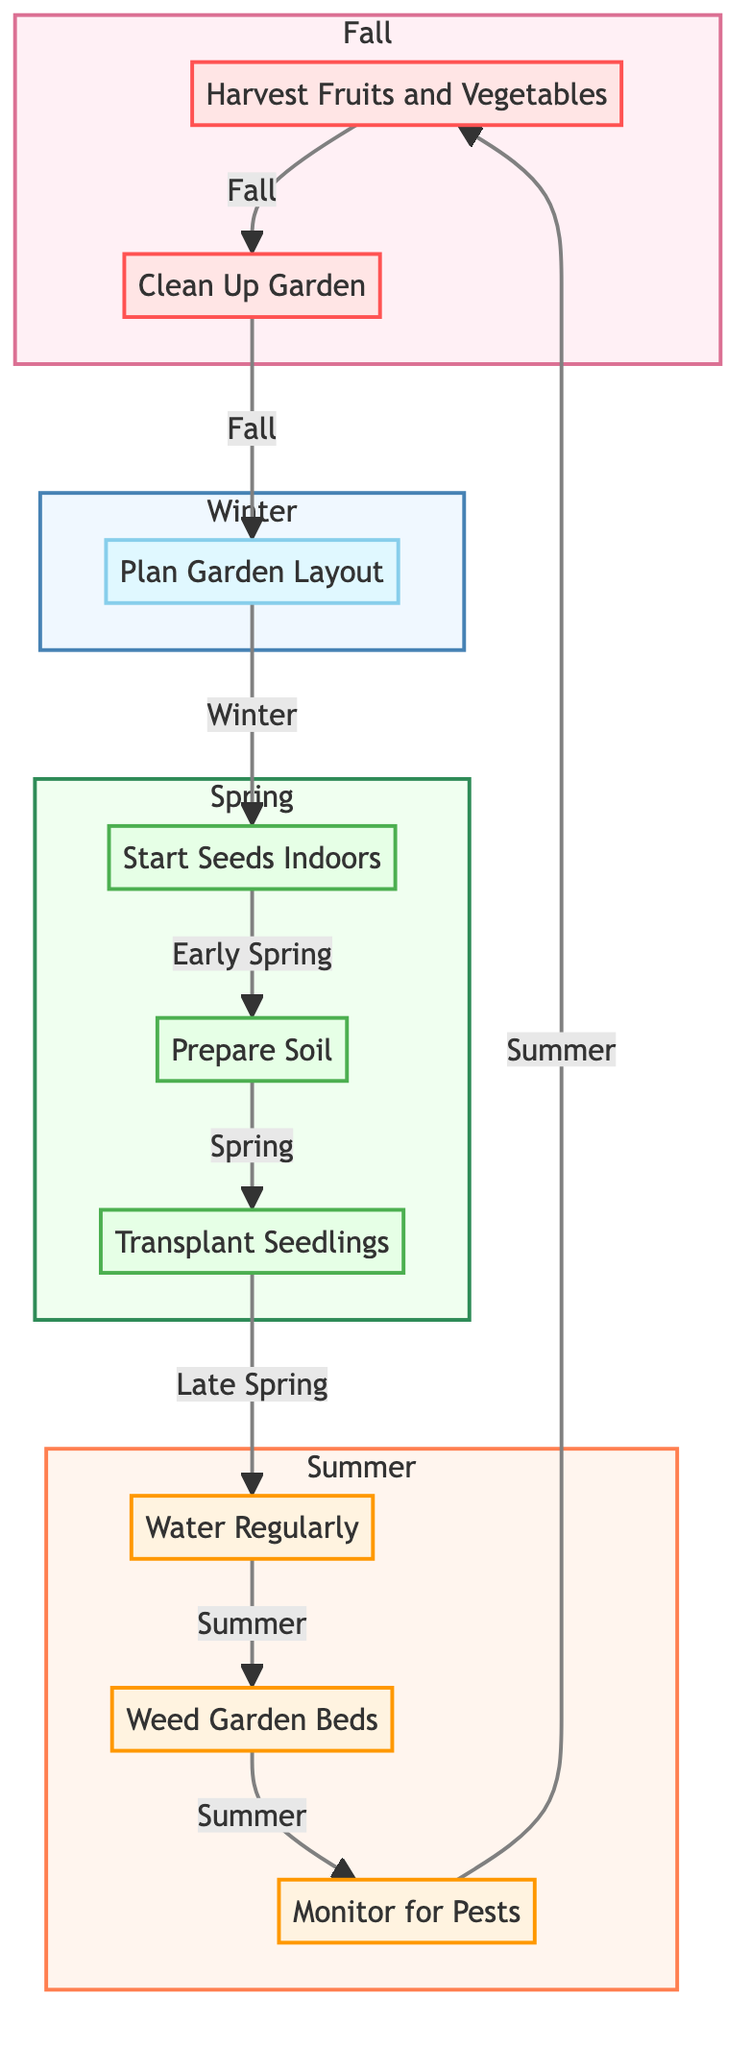What is the first task in the gardening flowchart? The flowchart starts with the node labeled "Plan Garden Layout" which represents the first task categorized under Winter.
Answer: Plan Garden Layout How many tasks are associated with the Spring season? There are three tasks labeled under the Spring season: "Start Seeds Indoors", "Prepare Soil", and "Transplant Seedlings", making a total of three tasks for this season.
Answer: 3 What task follows "Weed Garden Beds"? The task that follows "Weed Garden Beds" in the flowchart is "Monitor for Pests", indicating the next step in the Summer season.
Answer: Monitor for Pests In which season do you "Harvest Fruits and Vegetables"? The task "Harvest Fruits and Vegetables" is located in the Fall section of the flowchart, indicating the specific season for this activity.
Answer: Fall If you want to prepare soil for planting, which task do you perform? The flowchart specifies "Prepare Soil" as the task to be performed during the Spring season when preparing for planting.
Answer: Prepare Soil Describe the relationship between "Transplant Seedlings" and "Water Regularly". "Transplant Seedlings" leads directly to "Water Regularly", showing that after transplanting seedlings, the next crucial task is to ensure they receive adequate water.
Answer: Leads to Which task comes after "Start Seeds Indoors"? The next task following "Start Seeds Indoors" is "Prepare Soil", indicating the sequential steps in the early part of the Spring season.
Answer: Prepare Soil What color represents the Summer season in the flowchart? The Summer season tasks are represented with an orange color scheme, indicating the warmest season in the chart’s visual representation.
Answer: Orange What is the purpose of the "Clean Up Garden" task? The "Clean Up Garden" task aims to remove dead plants and debris, and may also involve planting cover crops for winter, which is part of Fall maintenance.
Answer: Remove dead plants and debris 